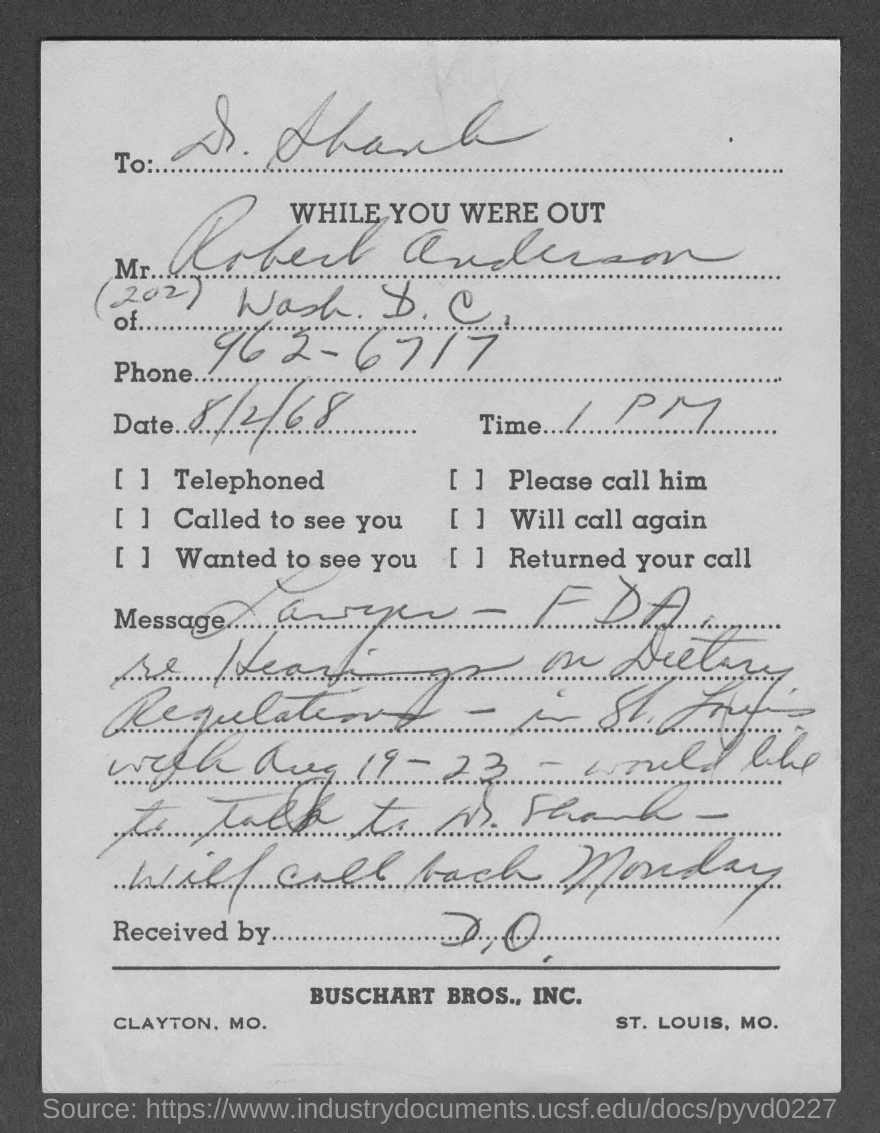Point out several critical features in this image. The letter is from Robert Anderson. The time is 1:00 PM. The date is August 2, 1968. The phone number is 962-6717. 